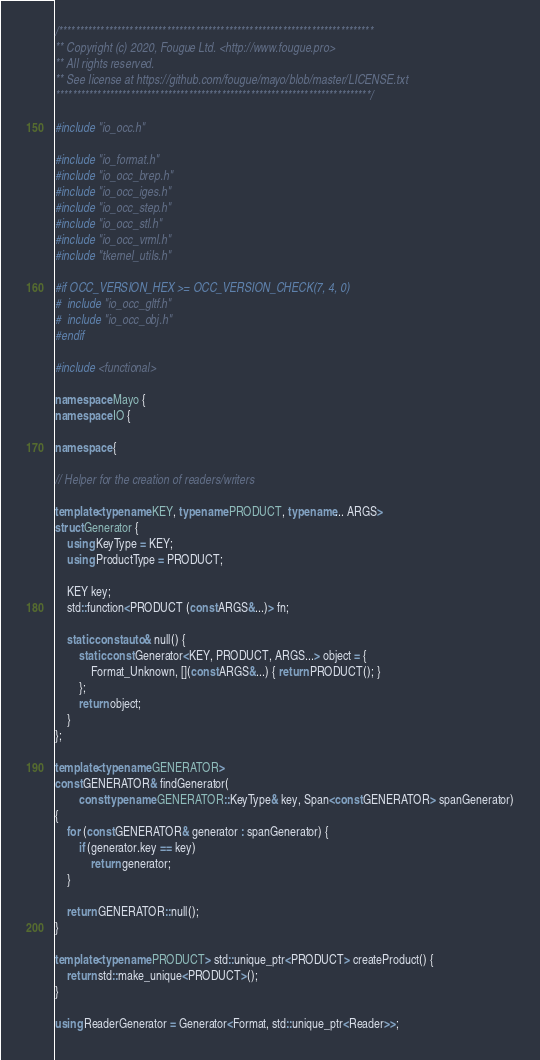<code> <loc_0><loc_0><loc_500><loc_500><_C++_>/****************************************************************************
** Copyright (c) 2020, Fougue Ltd. <http://www.fougue.pro>
** All rights reserved.
** See license at https://github.com/fougue/mayo/blob/master/LICENSE.txt
****************************************************************************/

#include "io_occ.h"

#include "io_format.h"
#include "io_occ_brep.h"
#include "io_occ_iges.h"
#include "io_occ_step.h"
#include "io_occ_stl.h"
#include "io_occ_vrml.h"
#include "tkernel_utils.h"

#if OCC_VERSION_HEX >= OCC_VERSION_CHECK(7, 4, 0)
#  include "io_occ_gltf.h"
#  include "io_occ_obj.h"
#endif

#include <functional>

namespace Mayo {
namespace IO {

namespace {

// Helper for the creation of readers/writers

template<typename KEY, typename PRODUCT, typename... ARGS>
struct Generator {
    using KeyType = KEY;
    using ProductType = PRODUCT;

    KEY key;
    std::function<PRODUCT (const ARGS&...)> fn;

    static const auto& null() {
        static const Generator<KEY, PRODUCT, ARGS...> object = {
            Format_Unknown, [](const ARGS&...) { return PRODUCT(); }
        };
        return object;
    }
};

template<typename GENERATOR>
const GENERATOR& findGenerator(
        const typename GENERATOR::KeyType& key, Span<const GENERATOR> spanGenerator)
{
    for (const GENERATOR& generator : spanGenerator) {
        if (generator.key == key)
            return generator;
    }

    return GENERATOR::null();
}

template<typename PRODUCT> std::unique_ptr<PRODUCT> createProduct() {
    return std::make_unique<PRODUCT>();
}

using ReaderGenerator = Generator<Format, std::unique_ptr<Reader>>;</code> 